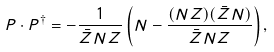<formula> <loc_0><loc_0><loc_500><loc_500>P \cdot P ^ { \dagger } = - \frac { 1 } { \bar { Z } N Z } \left ( N - \frac { ( N Z ) ( \bar { Z } N ) } { \bar { Z } N Z } \right ) ,</formula> 